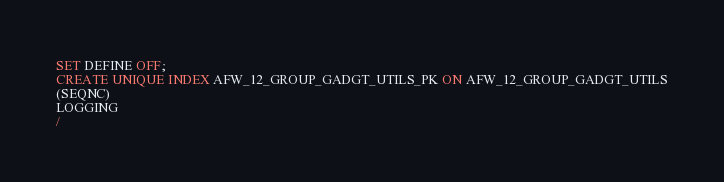Convert code to text. <code><loc_0><loc_0><loc_500><loc_500><_SQL_>SET DEFINE OFF;
CREATE UNIQUE INDEX AFW_12_GROUP_GADGT_UTILS_PK ON AFW_12_GROUP_GADGT_UTILS
(SEQNC)
LOGGING
/
</code> 